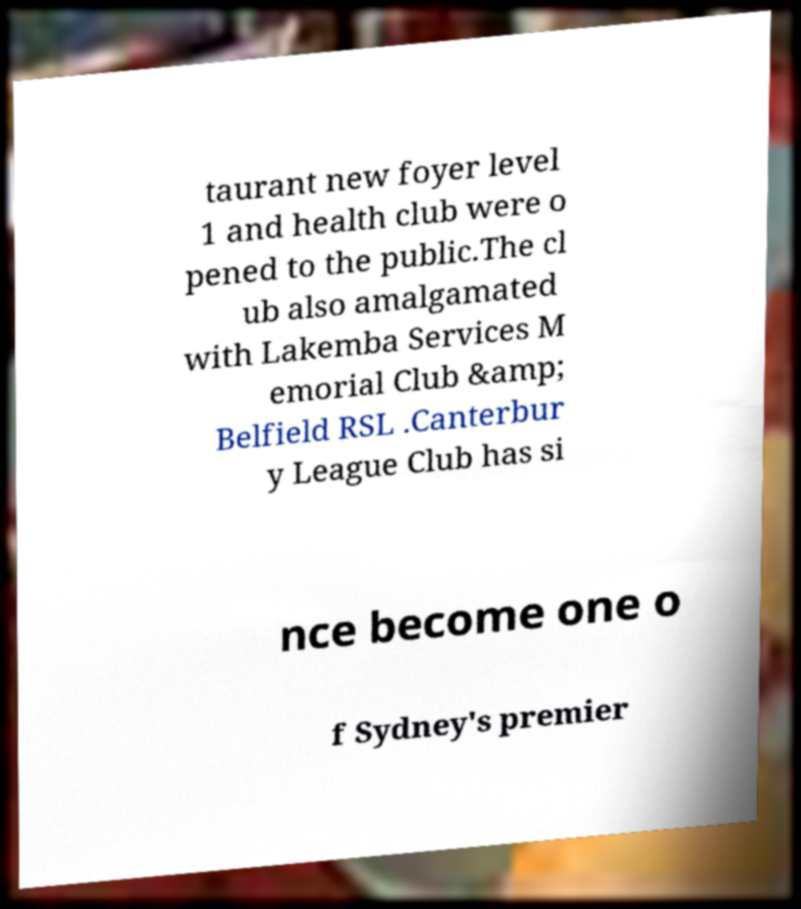Can you accurately transcribe the text from the provided image for me? taurant new foyer level 1 and health club were o pened to the public.The cl ub also amalgamated with Lakemba Services M emorial Club &amp; Belfield RSL .Canterbur y League Club has si nce become one o f Sydney's premier 